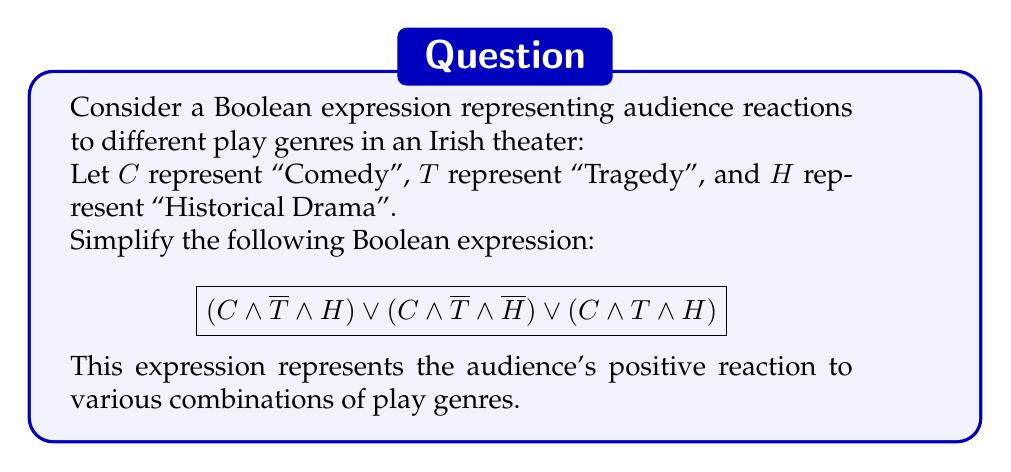Help me with this question. Let's simplify this Boolean expression step by step:

1) First, we can factor out the common term $C$ from all three terms:

   $C \land [(\overline{T} \land H) \lor (\overline{T} \land \overline{H}) \lor (T \land H)]$

2) Inside the square brackets, we can further simplify:
   $(\overline{T} \land H) \lor (\overline{T} \land \overline{H})$ can be factored as $\overline{T} \land (H \lor \overline{H})$

3) $(H \lor \overline{H})$ is always true (1 in Boolean algebra), so this simplifies to just $\overline{T}$

4) Now our expression looks like:

   $C \land [\overline{T} \lor (T \land H)]$

5) We can apply the absorption law here: $\overline{T} \lor (T \land H) = \overline{T} \lor H$

6) Therefore, our final simplified expression is:

   $C \land (\overline{T} \lor H)$

This means the audience reacts positively to comedies that are either not tragedies or are historical dramas (or both).
Answer: $C \land (\overline{T} \lor H)$ 